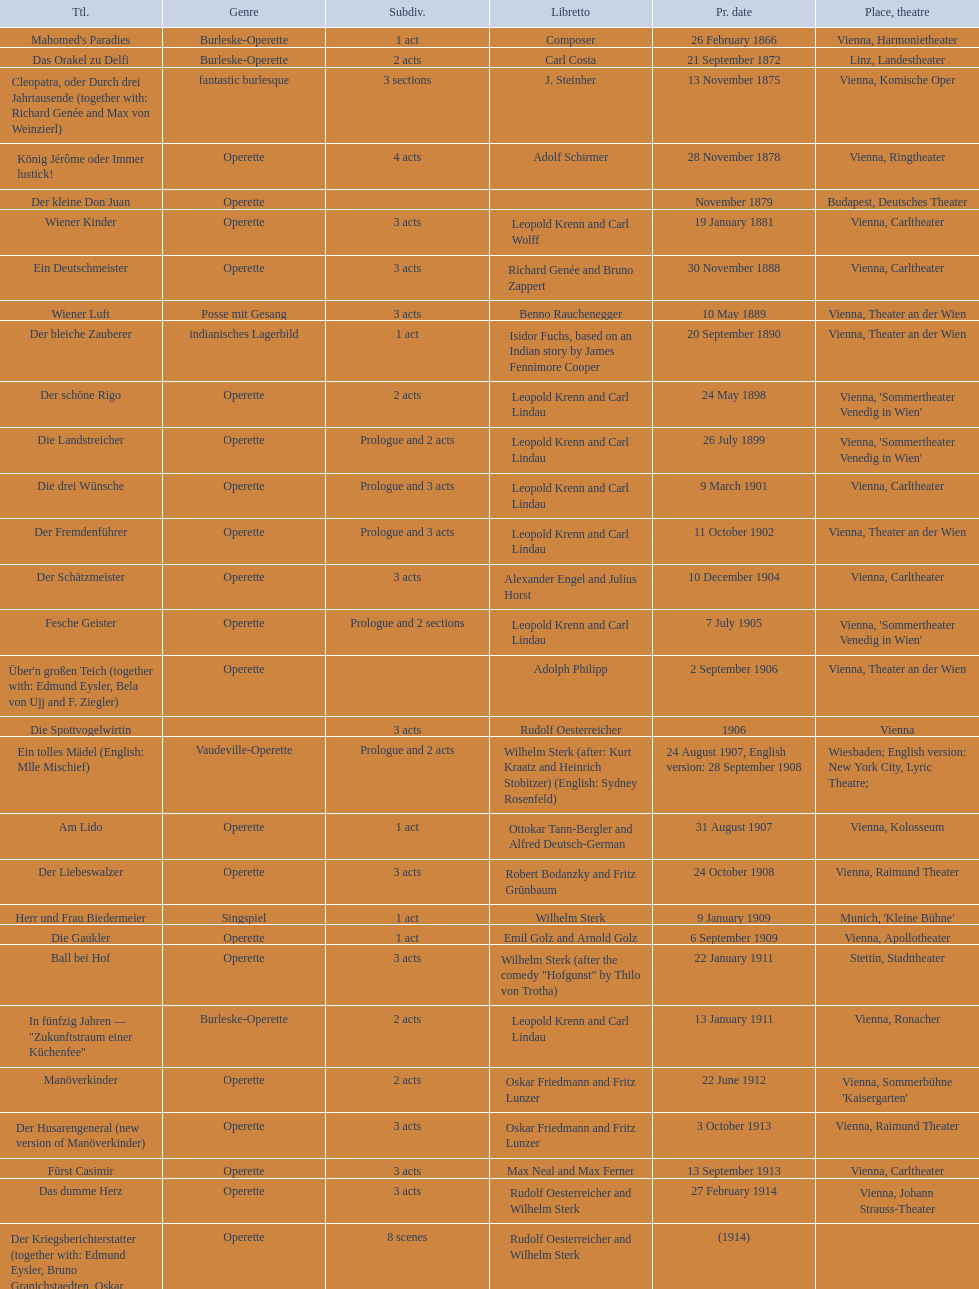How many of his operettas were 3 acts? 13. Could you parse the entire table as a dict? {'header': ['Ttl.', 'Genre', 'Sub\xaddiv.', 'Libretto', 'Pr. date', 'Place, theatre'], 'rows': [["Mahomed's Paradies", 'Burleske-Operette', '1 act', 'Composer', '26 February 1866', 'Vienna, Harmonietheater'], ['Das Orakel zu Delfi', 'Burleske-Operette', '2 acts', 'Carl Costa', '21 September 1872', 'Linz, Landestheater'], ['Cleopatra, oder Durch drei Jahrtausende (together with: Richard Genée and Max von Weinzierl)', 'fantastic burlesque', '3 sections', 'J. Steinher', '13 November 1875', 'Vienna, Komische Oper'], ['König Jérôme oder Immer lustick!', 'Operette', '4 acts', 'Adolf Schirmer', '28 November 1878', 'Vienna, Ringtheater'], ['Der kleine Don Juan', 'Operette', '', '', 'November 1879', 'Budapest, Deutsches Theater'], ['Wiener Kinder', 'Operette', '3 acts', 'Leopold Krenn and Carl Wolff', '19 January 1881', 'Vienna, Carltheater'], ['Ein Deutschmeister', 'Operette', '3 acts', 'Richard Genée and Bruno Zappert', '30 November 1888', 'Vienna, Carltheater'], ['Wiener Luft', 'Posse mit Gesang', '3 acts', 'Benno Rauchenegger', '10 May 1889', 'Vienna, Theater an der Wien'], ['Der bleiche Zauberer', 'indianisches Lagerbild', '1 act', 'Isidor Fuchs, based on an Indian story by James Fennimore Cooper', '20 September 1890', 'Vienna, Theater an der Wien'], ['Der schöne Rigo', 'Operette', '2 acts', 'Leopold Krenn and Carl Lindau', '24 May 1898', "Vienna, 'Sommertheater Venedig in Wien'"], ['Die Landstreicher', 'Operette', 'Prologue and 2 acts', 'Leopold Krenn and Carl Lindau', '26 July 1899', "Vienna, 'Sommertheater Venedig in Wien'"], ['Die drei Wünsche', 'Operette', 'Prologue and 3 acts', 'Leopold Krenn and Carl Lindau', '9 March 1901', 'Vienna, Carltheater'], ['Der Fremdenführer', 'Operette', 'Prologue and 3 acts', 'Leopold Krenn and Carl Lindau', '11 October 1902', 'Vienna, Theater an der Wien'], ['Der Schätzmeister', 'Operette', '3 acts', 'Alexander Engel and Julius Horst', '10 December 1904', 'Vienna, Carltheater'], ['Fesche Geister', 'Operette', 'Prologue and 2 sections', 'Leopold Krenn and Carl Lindau', '7 July 1905', "Vienna, 'Sommertheater Venedig in Wien'"], ["Über'n großen Teich (together with: Edmund Eysler, Bela von Ujj and F. Ziegler)", 'Operette', '', 'Adolph Philipp', '2 September 1906', 'Vienna, Theater an der Wien'], ['Die Spottvogelwirtin', '', '3 acts', 'Rudolf Oesterreicher', '1906', 'Vienna'], ['Ein tolles Mädel (English: Mlle Mischief)', 'Vaudeville-Operette', 'Prologue and 2 acts', 'Wilhelm Sterk (after: Kurt Kraatz and Heinrich Stobitzer) (English: Sydney Rosenfeld)', '24 August 1907, English version: 28 September 1908', 'Wiesbaden; English version: New York City, Lyric Theatre;'], ['Am Lido', 'Operette', '1 act', 'Ottokar Tann-Bergler and Alfred Deutsch-German', '31 August 1907', 'Vienna, Kolosseum'], ['Der Liebeswalzer', 'Operette', '3 acts', 'Robert Bodanzky and Fritz Grünbaum', '24 October 1908', 'Vienna, Raimund Theater'], ['Herr und Frau Biedermeier', 'Singspiel', '1 act', 'Wilhelm Sterk', '9 January 1909', "Munich, 'Kleine Bühne'"], ['Die Gaukler', 'Operette', '1 act', 'Emil Golz and Arnold Golz', '6 September 1909', 'Vienna, Apollotheater'], ['Ball bei Hof', 'Operette', '3 acts', 'Wilhelm Sterk (after the comedy "Hofgunst" by Thilo von Trotha)', '22 January 1911', 'Stettin, Stadttheater'], ['In fünfzig Jahren — "Zukunftstraum einer Küchenfee"', 'Burleske-Operette', '2 acts', 'Leopold Krenn and Carl Lindau', '13 January 1911', 'Vienna, Ronacher'], ['Manöverkinder', 'Operette', '2 acts', 'Oskar Friedmann and Fritz Lunzer', '22 June 1912', "Vienna, Sommerbühne 'Kaisergarten'"], ['Der Husarengeneral (new version of Manöverkinder)', 'Operette', '3 acts', 'Oskar Friedmann and Fritz Lunzer', '3 October 1913', 'Vienna, Raimund Theater'], ['Fürst Casimir', 'Operette', '3 acts', 'Max Neal and Max Ferner', '13 September 1913', 'Vienna, Carltheater'], ['Das dumme Herz', 'Operette', '3 acts', 'Rudolf Oesterreicher and Wilhelm Sterk', '27 February 1914', 'Vienna, Johann Strauss-Theater'], ['Der Kriegsberichterstatter (together with: Edmund Eysler, Bruno Granichstaedten, Oskar Nedbal, Charles Weinberger)', 'Operette', '8 scenes', 'Rudolf Oesterreicher and Wilhelm Sterk', '(1914)', ''], ['Im siebenten Himmel', 'Operette', '3 acts', 'Max Neal and Max Ferner', '26 February 1916', 'Munich, Theater am Gärtnerplatz'], ['Deutschmeisterkapelle', 'Operette', '', 'Hubert Marischka and Rudolf Oesterreicher', '30 May 1958', 'Vienna, Raimund Theater'], ['Die verliebte Eskadron', 'Operette', '3 acts', 'Wilhelm Sterk (after B. Buchbinder)', '11 July 1930', 'Vienna, Johann-Strauß-Theater']]} 